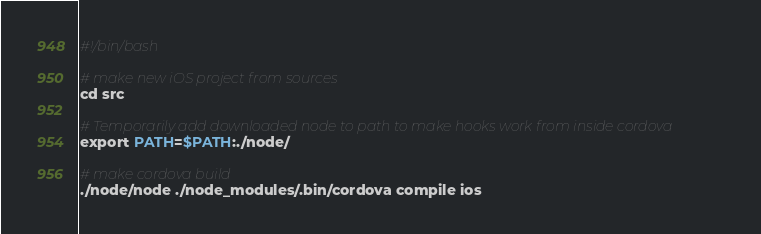<code> <loc_0><loc_0><loc_500><loc_500><_Bash_>#!/bin/bash

# make new iOS project from sources
cd src

# Temporarily add downloaded node to path to make hooks work from inside cordova
export PATH=$PATH:./node/

# make cordova build
./node/node ./node_modules/.bin/cordova compile ios
</code> 